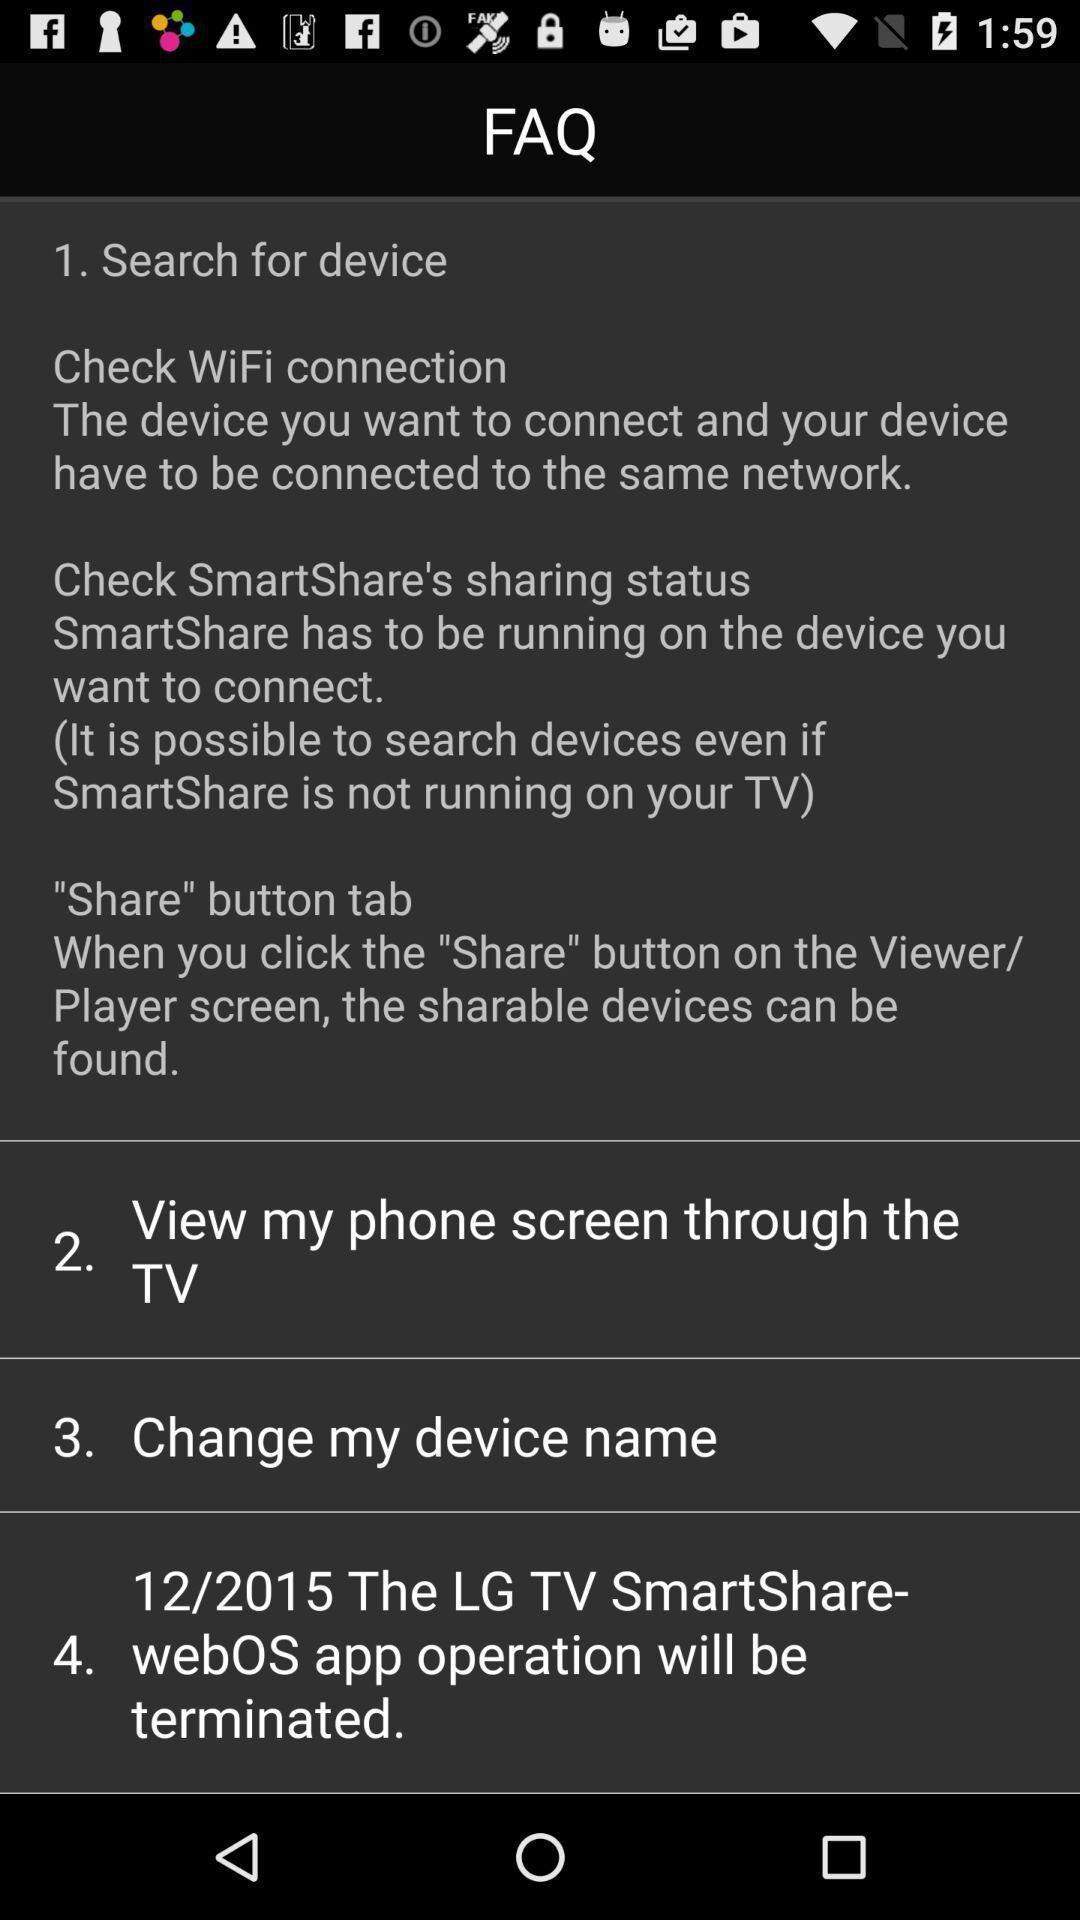What can you discern from this picture? Screen displaying faq about the smart tv. 